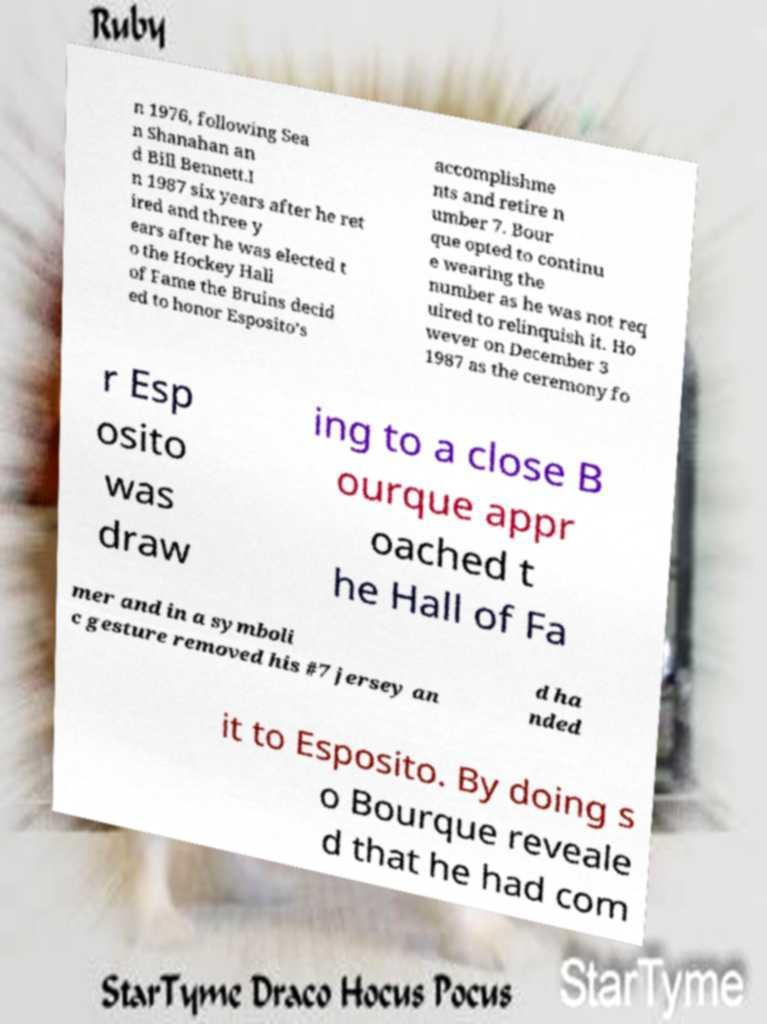What messages or text are displayed in this image? I need them in a readable, typed format. n 1976, following Sea n Shanahan an d Bill Bennett.I n 1987 six years after he ret ired and three y ears after he was elected t o the Hockey Hall of Fame the Bruins decid ed to honor Esposito’s accomplishme nts and retire n umber 7. Bour que opted to continu e wearing the number as he was not req uired to relinquish it. Ho wever on December 3 1987 as the ceremony fo r Esp osito was draw ing to a close B ourque appr oached t he Hall of Fa mer and in a symboli c gesture removed his #7 jersey an d ha nded it to Esposito. By doing s o Bourque reveale d that he had com 